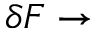Convert formula to latex. <formula><loc_0><loc_0><loc_500><loc_500>\delta F \rightarrow</formula> 